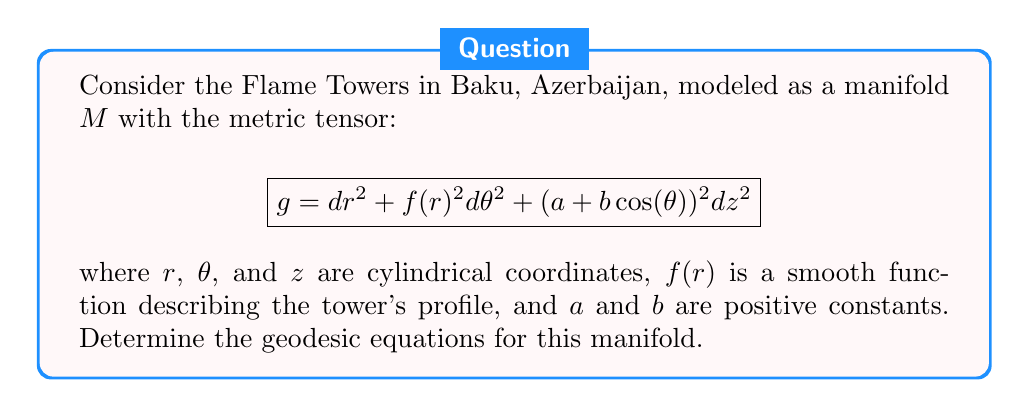Help me with this question. To find the geodesic equations, we'll use the Euler-Lagrange equations:

1) First, define the Lagrangian $L$:
   $$L = \frac{1}{2}(g_{ij}\dot{x}^i\dot{x}^j) = \frac{1}{2}(\dot{r}^2 + f(r)^2\dot{\theta}^2 + (a + b\cos(\theta))^2\dot{z}^2)$$

2) Apply the Euler-Lagrange equation for each coordinate:
   $$\frac{d}{dt}\left(\frac{\partial L}{\partial \dot{x}^i}\right) - \frac{\partial L}{\partial x^i} = 0$$

3) For $r$:
   $$\frac{d}{dt}(\dot{r}) - f(r)f'(r)\dot{\theta}^2 = 0$$
   $$\ddot{r} = f(r)f'(r)\dot{\theta}^2$$

4) For $\theta$:
   $$\frac{d}{dt}(f(r)^2\dot{\theta}) + b(a + b\cos(\theta))\sin(\theta)\dot{z}^2 = 0$$
   $$f(r)^2\ddot{\theta} + 2f(r)f'(r)\dot{r}\dot{\theta} + b(a + b\cos(\theta))\sin(\theta)\dot{z}^2 = 0$$

5) For $z$:
   $$\frac{d}{dt}((a + b\cos(\theta))^2\dot{z}) = 0$$
   $$(a + b\cos(\theta))^2\dot{z} = C$$ (constant)

These equations describe the geodesics on the manifold representing the Flame Towers.
Answer: $$\begin{cases}
\ddot{r} = f(r)f'(r)\dot{\theta}^2 \\
f(r)^2\ddot{\theta} + 2f(r)f'(r)\dot{r}\dot{\theta} + b(a + b\cos(\theta))\sin(\theta)\dot{z}^2 = 0 \\
(a + b\cos(\theta))^2\dot{z} = C
\end{cases}$$ 